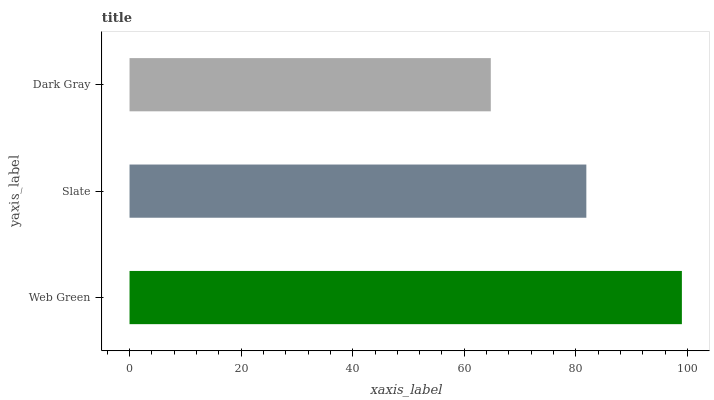Is Dark Gray the minimum?
Answer yes or no. Yes. Is Web Green the maximum?
Answer yes or no. Yes. Is Slate the minimum?
Answer yes or no. No. Is Slate the maximum?
Answer yes or no. No. Is Web Green greater than Slate?
Answer yes or no. Yes. Is Slate less than Web Green?
Answer yes or no. Yes. Is Slate greater than Web Green?
Answer yes or no. No. Is Web Green less than Slate?
Answer yes or no. No. Is Slate the high median?
Answer yes or no. Yes. Is Slate the low median?
Answer yes or no. Yes. Is Web Green the high median?
Answer yes or no. No. Is Web Green the low median?
Answer yes or no. No. 